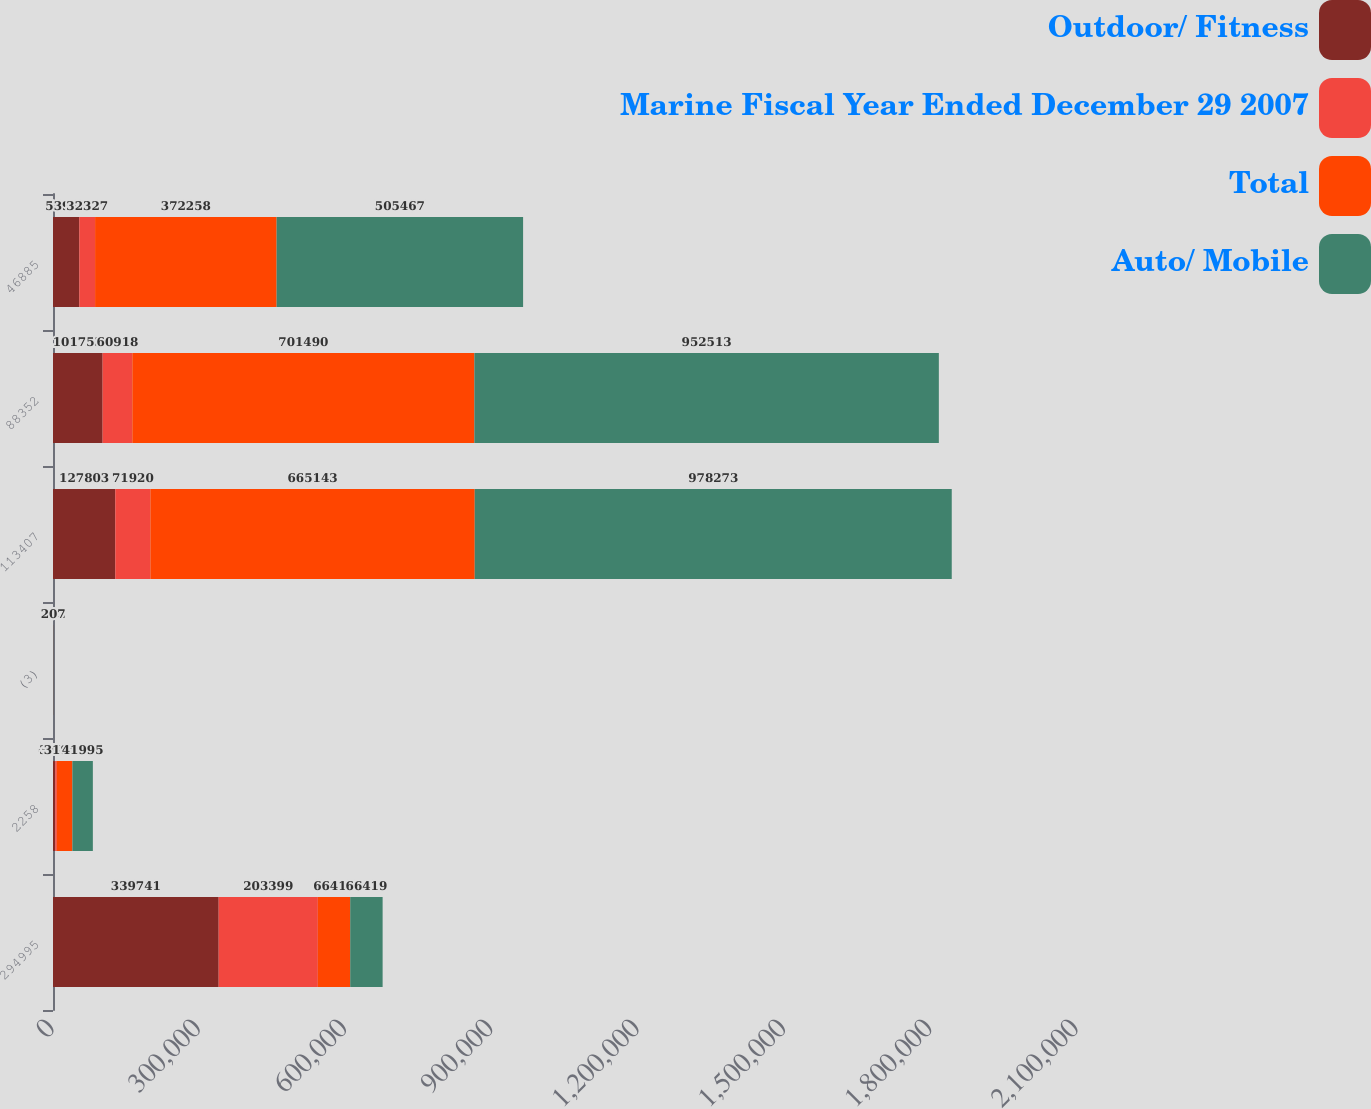<chart> <loc_0><loc_0><loc_500><loc_500><stacked_bar_chart><ecel><fcel>294995<fcel>2258<fcel>(3)<fcel>113407<fcel>88352<fcel>46885<nl><fcel>Outdoor/ Fitness<fcel>339741<fcel>4661<fcel>92<fcel>127803<fcel>101753<fcel>53997<nl><fcel>Marine Fiscal Year Ended December 29 2007<fcel>203399<fcel>3127<fcel>10<fcel>71920<fcel>60918<fcel>32327<nl><fcel>Total<fcel>66419<fcel>31949<fcel>102<fcel>665143<fcel>701490<fcel>372258<nl><fcel>Auto/ Mobile<fcel>66419<fcel>41995<fcel>207<fcel>978273<fcel>952513<fcel>505467<nl></chart> 